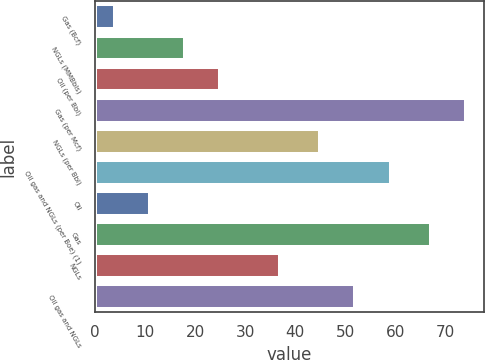Convert chart. <chart><loc_0><loc_0><loc_500><loc_500><bar_chart><fcel>Gas (Bcf)<fcel>NGLs (MMBbls)<fcel>Oil (per Bbl)<fcel>Gas (per Mcf)<fcel>NGLs (per Bbl)<fcel>Oil gas and NGLs (per Boe) (1)<fcel>Oil<fcel>Gas<fcel>NGLs<fcel>Oil gas and NGLs<nl><fcel>4<fcel>18<fcel>25<fcel>74<fcel>45<fcel>59<fcel>11<fcel>67<fcel>37<fcel>52<nl></chart> 